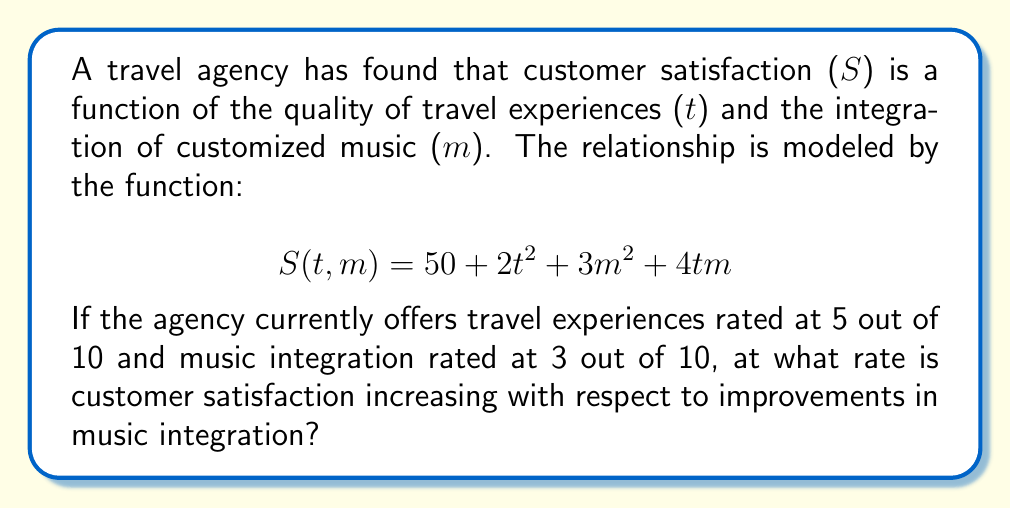Show me your answer to this math problem. To solve this problem, we need to find the partial derivative of $S$ with respect to $m$ and then evaluate it at the given point.

Step 1: Find the partial derivative of $S$ with respect to $m$.
$$\frac{\partial S}{\partial m} = 6m + 4t$$

Step 2: Substitute the given values: $t = 5$ and $m = 3$.
$$\frac{\partial S}{\partial m}\bigg|_{(5,3)} = 6(3) + 4(5)$$

Step 3: Calculate the result.
$$\frac{\partial S}{\partial m}\bigg|_{(5,3)} = 18 + 20 = 38$$

This means that at the current levels of travel experience quality (5) and music integration (3), customer satisfaction is increasing at a rate of 38 units per unit increase in music integration.
Answer: $38$ 